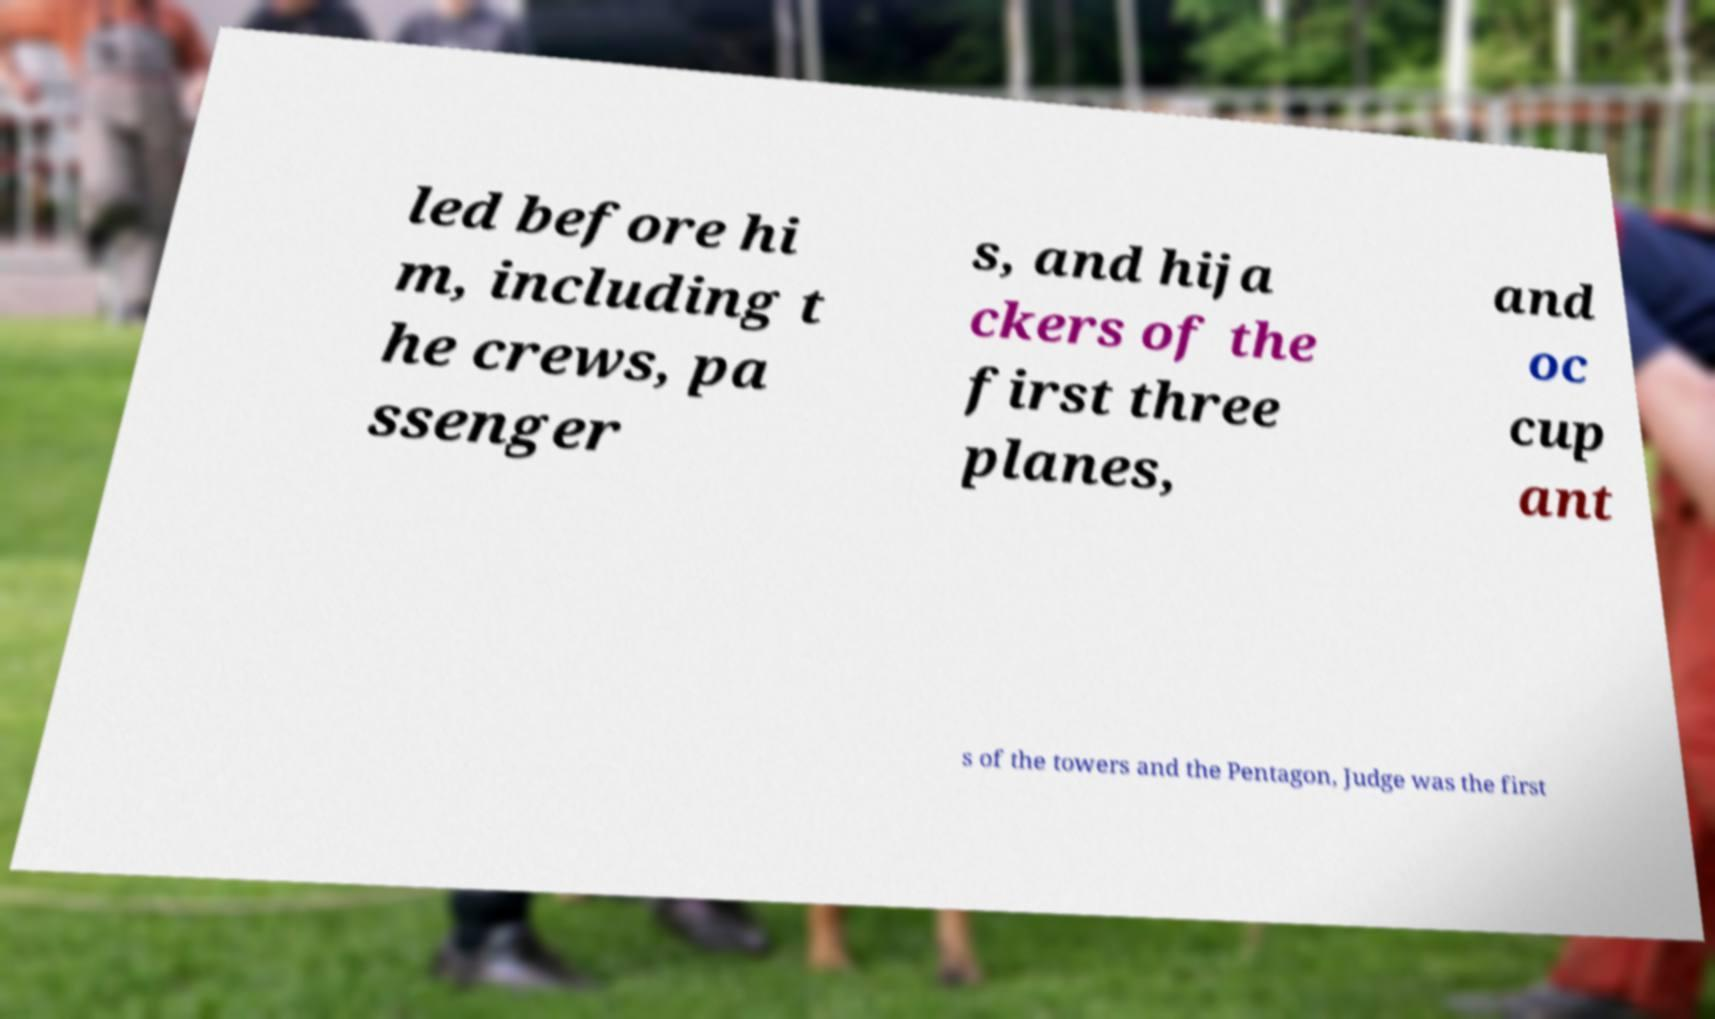I need the written content from this picture converted into text. Can you do that? led before hi m, including t he crews, pa ssenger s, and hija ckers of the first three planes, and oc cup ant s of the towers and the Pentagon, Judge was the first 